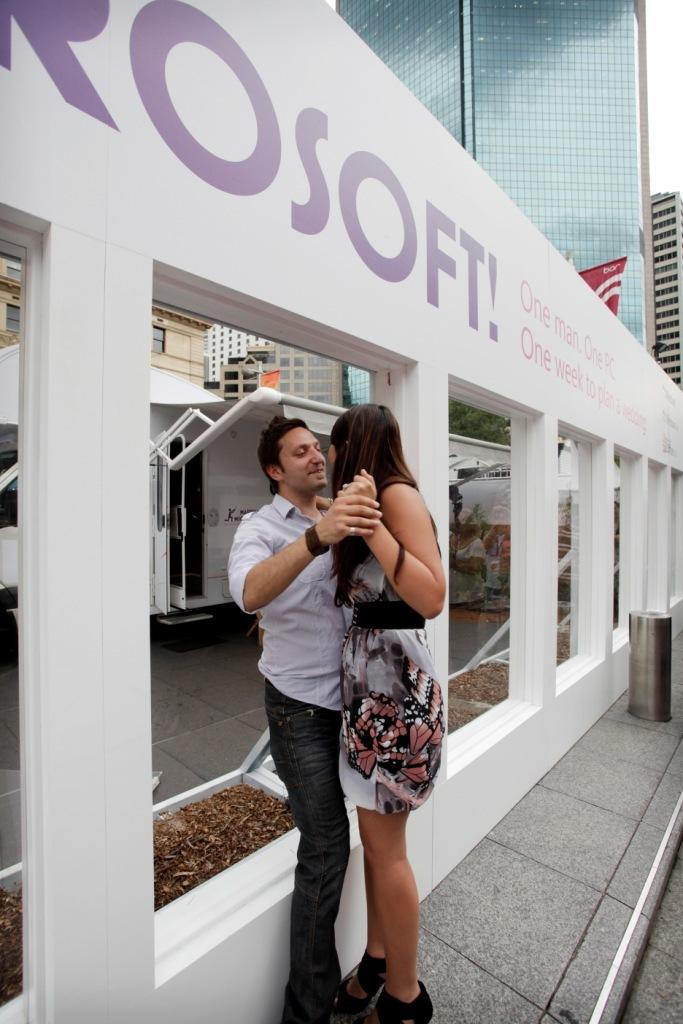How many people are in the image? There are two people in the image, a man and a woman. What are the man and woman doing in the image? The man and woman are standing together and holding hands. What can be seen in the background of the image? There are buildings in the background of the image. What type of prison can be seen in the background of the image? There is no prison present in the image; it features a man and a woman standing together and holding hands, with buildings in the background. What color is the soap that the man is holding in the image? There is no soap present in the image; the man and woman are holding hands. 